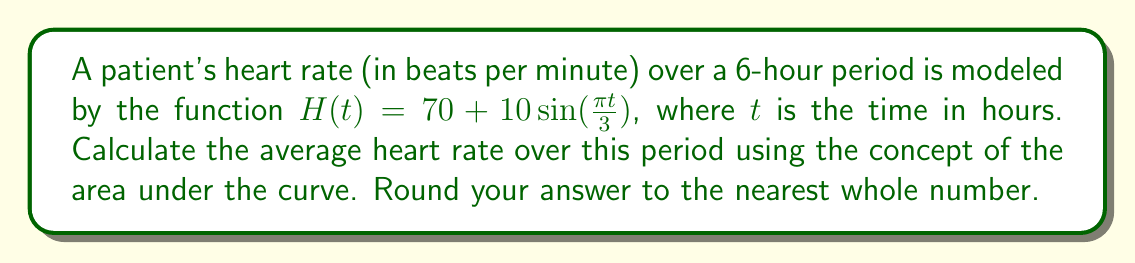Could you help me with this problem? To find the average heart rate, we need to:

1. Calculate the area under the curve (total heartbeats)
2. Divide the area by the time period (6 hours)

Step 1: Calculate the area under the curve

The area under the curve is given by the definite integral:

$$\int_0^6 (70 + 10\sin(\frac{\pi t}{3})) dt$$

Let's solve this integral:

$$\begin{align}
\int_0^6 (70 + 10\sin(\frac{\pi t}{3})) dt &= \left[70t - \frac{30}{\pi}\cos(\frac{\pi t}{3})\right]_0^6 \\
&= \left(70 \cdot 6 - \frac{30}{\pi}\cos(2\pi)\right) - \left(70 \cdot 0 - \frac{30}{\pi}\cos(0)\right) \\
&= 420 - \frac{30}{\pi} - (-\frac{30}{\pi}) \\
&= 420
\end{align}$$

Step 2: Calculate the average heart rate

Average heart rate = Total heartbeats / Time period
$$ \frac{420}{6} = 70 \text{ beats per minute}$$

Therefore, the average heart rate over the 6-hour period is 70 beats per minute.
Answer: 70 beats per minute 